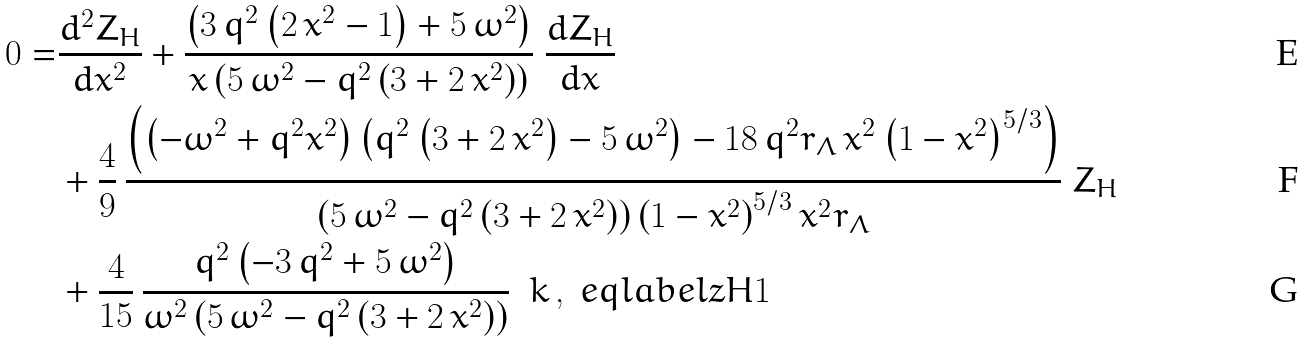<formula> <loc_0><loc_0><loc_500><loc_500>0 = & { \frac { d ^ { 2 } { Z _ { H } } } { d { x } ^ { 2 } } } + { \frac { \left ( 3 \, { q } ^ { 2 } \left ( 2 \, { x } ^ { 2 } - 1 \right ) + 5 \, { \omega } ^ { 2 } \right ) } { x \left ( 5 \, { \omega } ^ { 2 } - { q } ^ { 2 } \left ( 3 + 2 \, { x } ^ { 2 } \right ) \right ) } } \ { \frac { d { Z _ { H } } } { d x } } \\ & + \frac { 4 } { 9 } \, { \frac { \left ( \left ( - { \omega } ^ { 2 } + { q } ^ { 2 } { x } ^ { 2 } \right ) \left ( { q } ^ { 2 } \left ( 3 + 2 \, { x } ^ { 2 } \right ) - 5 \, { \omega } ^ { 2 } \right ) - 1 8 \, { q } ^ { 2 } { r _ { \Lambda } } \, { x } ^ { 2 } \left ( 1 - { x } ^ { 2 } \right ) ^ { 5 / 3 } \right ) } { \left ( 5 \, { \omega } ^ { 2 } - { q } ^ { 2 } \left ( 3 + 2 \, { x } ^ { 2 } \right ) \right ) \left ( 1 - { x } ^ { 2 } \right ) ^ { 5 / 3 } { x } ^ { 2 } { r _ { \Lambda } } } } \ { Z _ { H } } \\ & + { \frac { 4 } { 1 5 } } \, { \frac { { q } ^ { 2 } \left ( - 3 \, { q } ^ { 2 } + 5 \, { \omega } ^ { 2 } \right ) } { { \omega } ^ { 2 } \left ( 5 \, { \omega } ^ { 2 } - { q } ^ { 2 } \left ( 3 + 2 \, { x } ^ { 2 } \right ) \right ) } } \ \ k \, , \ e q l a b e l { z H 1 }</formula> 